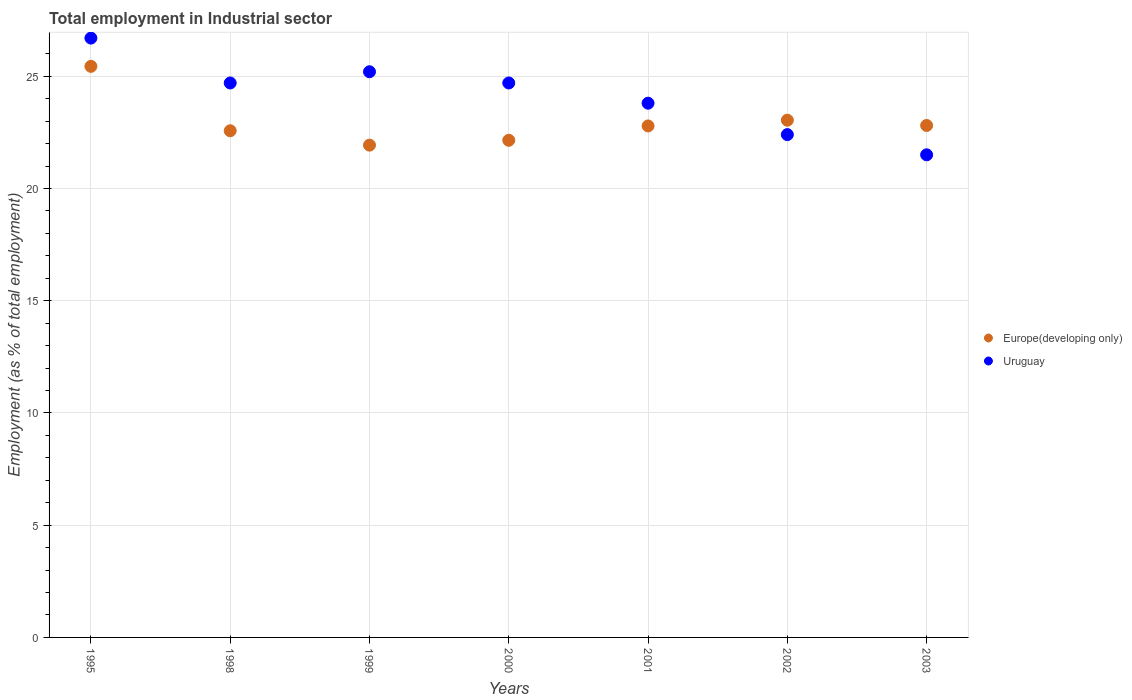How many different coloured dotlines are there?
Provide a succinct answer. 2. Is the number of dotlines equal to the number of legend labels?
Keep it short and to the point. Yes. What is the employment in industrial sector in Uruguay in 2003?
Offer a very short reply. 21.5. Across all years, what is the maximum employment in industrial sector in Europe(developing only)?
Offer a very short reply. 25.44. In which year was the employment in industrial sector in Uruguay maximum?
Offer a terse response. 1995. What is the total employment in industrial sector in Uruguay in the graph?
Provide a short and direct response. 169. What is the difference between the employment in industrial sector in Europe(developing only) in 2002 and the employment in industrial sector in Uruguay in 2003?
Your response must be concise. 1.54. What is the average employment in industrial sector in Europe(developing only) per year?
Your answer should be very brief. 22.96. In the year 1999, what is the difference between the employment in industrial sector in Uruguay and employment in industrial sector in Europe(developing only)?
Your answer should be very brief. 3.27. In how many years, is the employment in industrial sector in Europe(developing only) greater than 23 %?
Your response must be concise. 2. What is the ratio of the employment in industrial sector in Uruguay in 1999 to that in 2000?
Give a very brief answer. 1.02. Is the employment in industrial sector in Uruguay in 1998 less than that in 2001?
Ensure brevity in your answer.  No. What is the difference between the highest and the lowest employment in industrial sector in Uruguay?
Your answer should be very brief. 5.2. In how many years, is the employment in industrial sector in Uruguay greater than the average employment in industrial sector in Uruguay taken over all years?
Keep it short and to the point. 4. Is the sum of the employment in industrial sector in Uruguay in 2001 and 2002 greater than the maximum employment in industrial sector in Europe(developing only) across all years?
Provide a succinct answer. Yes. Is the employment in industrial sector in Uruguay strictly greater than the employment in industrial sector in Europe(developing only) over the years?
Make the answer very short. No. How many dotlines are there?
Give a very brief answer. 2. Are the values on the major ticks of Y-axis written in scientific E-notation?
Your answer should be compact. No. Does the graph contain any zero values?
Offer a terse response. No. What is the title of the graph?
Make the answer very short. Total employment in Industrial sector. Does "Zimbabwe" appear as one of the legend labels in the graph?
Your answer should be very brief. No. What is the label or title of the Y-axis?
Make the answer very short. Employment (as % of total employment). What is the Employment (as % of total employment) of Europe(developing only) in 1995?
Offer a terse response. 25.44. What is the Employment (as % of total employment) of Uruguay in 1995?
Offer a very short reply. 26.7. What is the Employment (as % of total employment) in Europe(developing only) in 1998?
Your answer should be very brief. 22.57. What is the Employment (as % of total employment) in Uruguay in 1998?
Your answer should be very brief. 24.7. What is the Employment (as % of total employment) in Europe(developing only) in 1999?
Provide a short and direct response. 21.93. What is the Employment (as % of total employment) of Uruguay in 1999?
Give a very brief answer. 25.2. What is the Employment (as % of total employment) in Europe(developing only) in 2000?
Keep it short and to the point. 22.15. What is the Employment (as % of total employment) in Uruguay in 2000?
Give a very brief answer. 24.7. What is the Employment (as % of total employment) in Europe(developing only) in 2001?
Your answer should be compact. 22.79. What is the Employment (as % of total employment) of Uruguay in 2001?
Give a very brief answer. 23.8. What is the Employment (as % of total employment) of Europe(developing only) in 2002?
Give a very brief answer. 23.04. What is the Employment (as % of total employment) in Uruguay in 2002?
Offer a very short reply. 22.4. What is the Employment (as % of total employment) in Europe(developing only) in 2003?
Your answer should be very brief. 22.81. What is the Employment (as % of total employment) in Uruguay in 2003?
Provide a succinct answer. 21.5. Across all years, what is the maximum Employment (as % of total employment) in Europe(developing only)?
Keep it short and to the point. 25.44. Across all years, what is the maximum Employment (as % of total employment) in Uruguay?
Offer a very short reply. 26.7. Across all years, what is the minimum Employment (as % of total employment) in Europe(developing only)?
Offer a terse response. 21.93. What is the total Employment (as % of total employment) in Europe(developing only) in the graph?
Your response must be concise. 160.73. What is the total Employment (as % of total employment) in Uruguay in the graph?
Make the answer very short. 169. What is the difference between the Employment (as % of total employment) of Europe(developing only) in 1995 and that in 1998?
Give a very brief answer. 2.87. What is the difference between the Employment (as % of total employment) of Europe(developing only) in 1995 and that in 1999?
Make the answer very short. 3.51. What is the difference between the Employment (as % of total employment) of Europe(developing only) in 1995 and that in 2000?
Your answer should be compact. 3.29. What is the difference between the Employment (as % of total employment) in Uruguay in 1995 and that in 2000?
Your response must be concise. 2. What is the difference between the Employment (as % of total employment) in Europe(developing only) in 1995 and that in 2001?
Your answer should be compact. 2.66. What is the difference between the Employment (as % of total employment) in Europe(developing only) in 1995 and that in 2002?
Your response must be concise. 2.4. What is the difference between the Employment (as % of total employment) of Uruguay in 1995 and that in 2002?
Keep it short and to the point. 4.3. What is the difference between the Employment (as % of total employment) in Europe(developing only) in 1995 and that in 2003?
Give a very brief answer. 2.63. What is the difference between the Employment (as % of total employment) in Uruguay in 1995 and that in 2003?
Provide a short and direct response. 5.2. What is the difference between the Employment (as % of total employment) of Europe(developing only) in 1998 and that in 1999?
Make the answer very short. 0.64. What is the difference between the Employment (as % of total employment) in Uruguay in 1998 and that in 1999?
Ensure brevity in your answer.  -0.5. What is the difference between the Employment (as % of total employment) of Europe(developing only) in 1998 and that in 2000?
Your answer should be very brief. 0.42. What is the difference between the Employment (as % of total employment) of Uruguay in 1998 and that in 2000?
Your answer should be very brief. 0. What is the difference between the Employment (as % of total employment) of Europe(developing only) in 1998 and that in 2001?
Offer a terse response. -0.21. What is the difference between the Employment (as % of total employment) in Uruguay in 1998 and that in 2001?
Make the answer very short. 0.9. What is the difference between the Employment (as % of total employment) of Europe(developing only) in 1998 and that in 2002?
Keep it short and to the point. -0.47. What is the difference between the Employment (as % of total employment) of Uruguay in 1998 and that in 2002?
Provide a short and direct response. 2.3. What is the difference between the Employment (as % of total employment) in Europe(developing only) in 1998 and that in 2003?
Ensure brevity in your answer.  -0.24. What is the difference between the Employment (as % of total employment) in Europe(developing only) in 1999 and that in 2000?
Provide a short and direct response. -0.22. What is the difference between the Employment (as % of total employment) in Europe(developing only) in 1999 and that in 2001?
Your response must be concise. -0.85. What is the difference between the Employment (as % of total employment) of Europe(developing only) in 1999 and that in 2002?
Your answer should be compact. -1.11. What is the difference between the Employment (as % of total employment) in Uruguay in 1999 and that in 2002?
Provide a short and direct response. 2.8. What is the difference between the Employment (as % of total employment) in Europe(developing only) in 1999 and that in 2003?
Provide a succinct answer. -0.88. What is the difference between the Employment (as % of total employment) in Europe(developing only) in 2000 and that in 2001?
Your answer should be compact. -0.64. What is the difference between the Employment (as % of total employment) in Europe(developing only) in 2000 and that in 2002?
Provide a succinct answer. -0.9. What is the difference between the Employment (as % of total employment) of Europe(developing only) in 2000 and that in 2003?
Provide a short and direct response. -0.66. What is the difference between the Employment (as % of total employment) in Uruguay in 2000 and that in 2003?
Offer a very short reply. 3.2. What is the difference between the Employment (as % of total employment) of Europe(developing only) in 2001 and that in 2002?
Your answer should be compact. -0.26. What is the difference between the Employment (as % of total employment) in Uruguay in 2001 and that in 2002?
Your answer should be compact. 1.4. What is the difference between the Employment (as % of total employment) in Europe(developing only) in 2001 and that in 2003?
Provide a succinct answer. -0.02. What is the difference between the Employment (as % of total employment) of Europe(developing only) in 2002 and that in 2003?
Provide a short and direct response. 0.23. What is the difference between the Employment (as % of total employment) of Uruguay in 2002 and that in 2003?
Provide a short and direct response. 0.9. What is the difference between the Employment (as % of total employment) in Europe(developing only) in 1995 and the Employment (as % of total employment) in Uruguay in 1998?
Your response must be concise. 0.74. What is the difference between the Employment (as % of total employment) of Europe(developing only) in 1995 and the Employment (as % of total employment) of Uruguay in 1999?
Give a very brief answer. 0.24. What is the difference between the Employment (as % of total employment) of Europe(developing only) in 1995 and the Employment (as % of total employment) of Uruguay in 2000?
Keep it short and to the point. 0.74. What is the difference between the Employment (as % of total employment) of Europe(developing only) in 1995 and the Employment (as % of total employment) of Uruguay in 2001?
Your answer should be compact. 1.64. What is the difference between the Employment (as % of total employment) of Europe(developing only) in 1995 and the Employment (as % of total employment) of Uruguay in 2002?
Your response must be concise. 3.04. What is the difference between the Employment (as % of total employment) in Europe(developing only) in 1995 and the Employment (as % of total employment) in Uruguay in 2003?
Your answer should be compact. 3.94. What is the difference between the Employment (as % of total employment) in Europe(developing only) in 1998 and the Employment (as % of total employment) in Uruguay in 1999?
Offer a very short reply. -2.63. What is the difference between the Employment (as % of total employment) in Europe(developing only) in 1998 and the Employment (as % of total employment) in Uruguay in 2000?
Offer a terse response. -2.13. What is the difference between the Employment (as % of total employment) in Europe(developing only) in 1998 and the Employment (as % of total employment) in Uruguay in 2001?
Make the answer very short. -1.23. What is the difference between the Employment (as % of total employment) of Europe(developing only) in 1998 and the Employment (as % of total employment) of Uruguay in 2002?
Your answer should be very brief. 0.17. What is the difference between the Employment (as % of total employment) in Europe(developing only) in 1998 and the Employment (as % of total employment) in Uruguay in 2003?
Keep it short and to the point. 1.07. What is the difference between the Employment (as % of total employment) in Europe(developing only) in 1999 and the Employment (as % of total employment) in Uruguay in 2000?
Give a very brief answer. -2.77. What is the difference between the Employment (as % of total employment) in Europe(developing only) in 1999 and the Employment (as % of total employment) in Uruguay in 2001?
Offer a very short reply. -1.87. What is the difference between the Employment (as % of total employment) of Europe(developing only) in 1999 and the Employment (as % of total employment) of Uruguay in 2002?
Provide a succinct answer. -0.47. What is the difference between the Employment (as % of total employment) of Europe(developing only) in 1999 and the Employment (as % of total employment) of Uruguay in 2003?
Offer a very short reply. 0.43. What is the difference between the Employment (as % of total employment) of Europe(developing only) in 2000 and the Employment (as % of total employment) of Uruguay in 2001?
Your answer should be compact. -1.65. What is the difference between the Employment (as % of total employment) of Europe(developing only) in 2000 and the Employment (as % of total employment) of Uruguay in 2002?
Your answer should be very brief. -0.25. What is the difference between the Employment (as % of total employment) of Europe(developing only) in 2000 and the Employment (as % of total employment) of Uruguay in 2003?
Your answer should be very brief. 0.65. What is the difference between the Employment (as % of total employment) in Europe(developing only) in 2001 and the Employment (as % of total employment) in Uruguay in 2002?
Offer a very short reply. 0.39. What is the difference between the Employment (as % of total employment) of Europe(developing only) in 2001 and the Employment (as % of total employment) of Uruguay in 2003?
Your answer should be compact. 1.29. What is the difference between the Employment (as % of total employment) of Europe(developing only) in 2002 and the Employment (as % of total employment) of Uruguay in 2003?
Give a very brief answer. 1.54. What is the average Employment (as % of total employment) in Europe(developing only) per year?
Your answer should be compact. 22.96. What is the average Employment (as % of total employment) of Uruguay per year?
Your answer should be compact. 24.14. In the year 1995, what is the difference between the Employment (as % of total employment) of Europe(developing only) and Employment (as % of total employment) of Uruguay?
Your response must be concise. -1.26. In the year 1998, what is the difference between the Employment (as % of total employment) of Europe(developing only) and Employment (as % of total employment) of Uruguay?
Offer a terse response. -2.13. In the year 1999, what is the difference between the Employment (as % of total employment) of Europe(developing only) and Employment (as % of total employment) of Uruguay?
Your response must be concise. -3.27. In the year 2000, what is the difference between the Employment (as % of total employment) in Europe(developing only) and Employment (as % of total employment) in Uruguay?
Ensure brevity in your answer.  -2.55. In the year 2001, what is the difference between the Employment (as % of total employment) in Europe(developing only) and Employment (as % of total employment) in Uruguay?
Your answer should be compact. -1.01. In the year 2002, what is the difference between the Employment (as % of total employment) of Europe(developing only) and Employment (as % of total employment) of Uruguay?
Offer a terse response. 0.64. In the year 2003, what is the difference between the Employment (as % of total employment) in Europe(developing only) and Employment (as % of total employment) in Uruguay?
Your response must be concise. 1.31. What is the ratio of the Employment (as % of total employment) in Europe(developing only) in 1995 to that in 1998?
Ensure brevity in your answer.  1.13. What is the ratio of the Employment (as % of total employment) in Uruguay in 1995 to that in 1998?
Your answer should be very brief. 1.08. What is the ratio of the Employment (as % of total employment) in Europe(developing only) in 1995 to that in 1999?
Make the answer very short. 1.16. What is the ratio of the Employment (as % of total employment) in Uruguay in 1995 to that in 1999?
Your answer should be compact. 1.06. What is the ratio of the Employment (as % of total employment) of Europe(developing only) in 1995 to that in 2000?
Your response must be concise. 1.15. What is the ratio of the Employment (as % of total employment) of Uruguay in 1995 to that in 2000?
Give a very brief answer. 1.08. What is the ratio of the Employment (as % of total employment) in Europe(developing only) in 1995 to that in 2001?
Your answer should be compact. 1.12. What is the ratio of the Employment (as % of total employment) in Uruguay in 1995 to that in 2001?
Ensure brevity in your answer.  1.12. What is the ratio of the Employment (as % of total employment) of Europe(developing only) in 1995 to that in 2002?
Offer a terse response. 1.1. What is the ratio of the Employment (as % of total employment) of Uruguay in 1995 to that in 2002?
Your answer should be very brief. 1.19. What is the ratio of the Employment (as % of total employment) in Europe(developing only) in 1995 to that in 2003?
Provide a short and direct response. 1.12. What is the ratio of the Employment (as % of total employment) in Uruguay in 1995 to that in 2003?
Your response must be concise. 1.24. What is the ratio of the Employment (as % of total employment) of Europe(developing only) in 1998 to that in 1999?
Your response must be concise. 1.03. What is the ratio of the Employment (as % of total employment) in Uruguay in 1998 to that in 1999?
Give a very brief answer. 0.98. What is the ratio of the Employment (as % of total employment) of Europe(developing only) in 1998 to that in 2000?
Provide a short and direct response. 1.02. What is the ratio of the Employment (as % of total employment) of Europe(developing only) in 1998 to that in 2001?
Give a very brief answer. 0.99. What is the ratio of the Employment (as % of total employment) of Uruguay in 1998 to that in 2001?
Your response must be concise. 1.04. What is the ratio of the Employment (as % of total employment) in Europe(developing only) in 1998 to that in 2002?
Your answer should be compact. 0.98. What is the ratio of the Employment (as % of total employment) in Uruguay in 1998 to that in 2002?
Make the answer very short. 1.1. What is the ratio of the Employment (as % of total employment) in Uruguay in 1998 to that in 2003?
Offer a terse response. 1.15. What is the ratio of the Employment (as % of total employment) of Europe(developing only) in 1999 to that in 2000?
Your answer should be very brief. 0.99. What is the ratio of the Employment (as % of total employment) of Uruguay in 1999 to that in 2000?
Keep it short and to the point. 1.02. What is the ratio of the Employment (as % of total employment) of Europe(developing only) in 1999 to that in 2001?
Provide a short and direct response. 0.96. What is the ratio of the Employment (as % of total employment) of Uruguay in 1999 to that in 2001?
Give a very brief answer. 1.06. What is the ratio of the Employment (as % of total employment) of Europe(developing only) in 1999 to that in 2002?
Provide a short and direct response. 0.95. What is the ratio of the Employment (as % of total employment) in Uruguay in 1999 to that in 2002?
Offer a terse response. 1.12. What is the ratio of the Employment (as % of total employment) in Europe(developing only) in 1999 to that in 2003?
Give a very brief answer. 0.96. What is the ratio of the Employment (as % of total employment) in Uruguay in 1999 to that in 2003?
Keep it short and to the point. 1.17. What is the ratio of the Employment (as % of total employment) of Europe(developing only) in 2000 to that in 2001?
Provide a short and direct response. 0.97. What is the ratio of the Employment (as % of total employment) in Uruguay in 2000 to that in 2001?
Make the answer very short. 1.04. What is the ratio of the Employment (as % of total employment) of Europe(developing only) in 2000 to that in 2002?
Provide a succinct answer. 0.96. What is the ratio of the Employment (as % of total employment) in Uruguay in 2000 to that in 2002?
Give a very brief answer. 1.1. What is the ratio of the Employment (as % of total employment) in Europe(developing only) in 2000 to that in 2003?
Offer a very short reply. 0.97. What is the ratio of the Employment (as % of total employment) in Uruguay in 2000 to that in 2003?
Offer a terse response. 1.15. What is the ratio of the Employment (as % of total employment) of Europe(developing only) in 2001 to that in 2002?
Offer a very short reply. 0.99. What is the ratio of the Employment (as % of total employment) of Uruguay in 2001 to that in 2003?
Your answer should be compact. 1.11. What is the ratio of the Employment (as % of total employment) of Europe(developing only) in 2002 to that in 2003?
Provide a short and direct response. 1.01. What is the ratio of the Employment (as % of total employment) of Uruguay in 2002 to that in 2003?
Your answer should be compact. 1.04. What is the difference between the highest and the second highest Employment (as % of total employment) in Europe(developing only)?
Keep it short and to the point. 2.4. What is the difference between the highest and the lowest Employment (as % of total employment) of Europe(developing only)?
Offer a terse response. 3.51. 